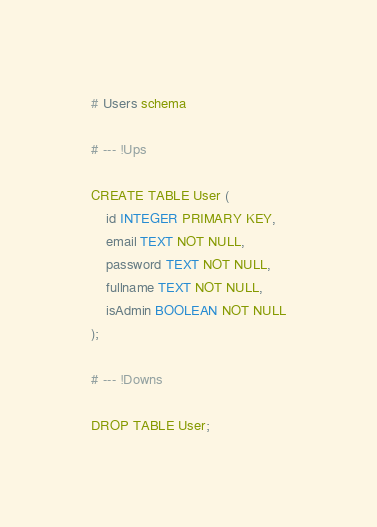<code> <loc_0><loc_0><loc_500><loc_500><_SQL_># Users schema

# --- !Ups

CREATE TABLE User (
    id INTEGER PRIMARY KEY,
    email TEXT NOT NULL,
    password TEXT NOT NULL,
    fullname TEXT NOT NULL,
    isAdmin BOOLEAN NOT NULL
);

# --- !Downs

DROP TABLE User;</code> 